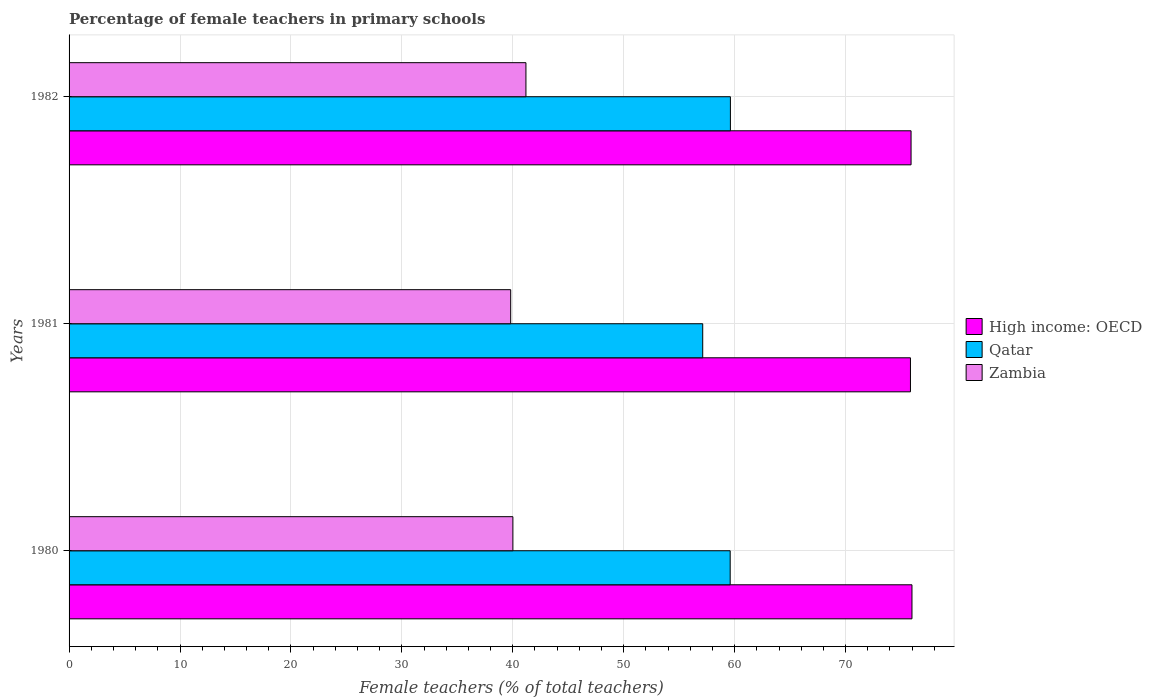How many different coloured bars are there?
Keep it short and to the point. 3. How many groups of bars are there?
Offer a very short reply. 3. Are the number of bars per tick equal to the number of legend labels?
Ensure brevity in your answer.  Yes. Are the number of bars on each tick of the Y-axis equal?
Your answer should be compact. Yes. How many bars are there on the 2nd tick from the top?
Give a very brief answer. 3. What is the label of the 1st group of bars from the top?
Keep it short and to the point. 1982. In how many cases, is the number of bars for a given year not equal to the number of legend labels?
Your answer should be very brief. 0. What is the percentage of female teachers in High income: OECD in 1981?
Offer a terse response. 75.85. Across all years, what is the maximum percentage of female teachers in Qatar?
Your answer should be very brief. 59.62. Across all years, what is the minimum percentage of female teachers in High income: OECD?
Give a very brief answer. 75.85. In which year was the percentage of female teachers in High income: OECD maximum?
Ensure brevity in your answer.  1980. What is the total percentage of female teachers in Qatar in the graph?
Ensure brevity in your answer.  176.34. What is the difference between the percentage of female teachers in High income: OECD in 1980 and that in 1982?
Your response must be concise. 0.08. What is the difference between the percentage of female teachers in High income: OECD in 1980 and the percentage of female teachers in Zambia in 1982?
Provide a succinct answer. 34.8. What is the average percentage of female teachers in High income: OECD per year?
Offer a terse response. 75.91. In the year 1982, what is the difference between the percentage of female teachers in High income: OECD and percentage of female teachers in Zambia?
Provide a succinct answer. 34.72. In how many years, is the percentage of female teachers in Qatar greater than 28 %?
Your answer should be compact. 3. What is the ratio of the percentage of female teachers in High income: OECD in 1980 to that in 1982?
Give a very brief answer. 1. What is the difference between the highest and the second highest percentage of female teachers in Zambia?
Offer a very short reply. 1.18. What is the difference between the highest and the lowest percentage of female teachers in Qatar?
Offer a very short reply. 2.5. In how many years, is the percentage of female teachers in Qatar greater than the average percentage of female teachers in Qatar taken over all years?
Your answer should be compact. 2. Is the sum of the percentage of female teachers in Qatar in 1980 and 1981 greater than the maximum percentage of female teachers in High income: OECD across all years?
Offer a terse response. Yes. What does the 1st bar from the top in 1981 represents?
Your answer should be very brief. Zambia. What does the 3rd bar from the bottom in 1980 represents?
Your response must be concise. Zambia. Are all the bars in the graph horizontal?
Ensure brevity in your answer.  Yes. How many years are there in the graph?
Keep it short and to the point. 3. Are the values on the major ticks of X-axis written in scientific E-notation?
Your answer should be very brief. No. Where does the legend appear in the graph?
Give a very brief answer. Center right. How many legend labels are there?
Your response must be concise. 3. How are the legend labels stacked?
Your answer should be very brief. Vertical. What is the title of the graph?
Keep it short and to the point. Percentage of female teachers in primary schools. What is the label or title of the X-axis?
Provide a short and direct response. Female teachers (% of total teachers). What is the Female teachers (% of total teachers) in High income: OECD in 1980?
Your answer should be very brief. 75.99. What is the Female teachers (% of total teachers) in Qatar in 1980?
Your answer should be very brief. 59.6. What is the Female teachers (% of total teachers) in Zambia in 1980?
Offer a very short reply. 40.01. What is the Female teachers (% of total teachers) in High income: OECD in 1981?
Keep it short and to the point. 75.85. What is the Female teachers (% of total teachers) in Qatar in 1981?
Ensure brevity in your answer.  57.12. What is the Female teachers (% of total teachers) of Zambia in 1981?
Ensure brevity in your answer.  39.81. What is the Female teachers (% of total teachers) of High income: OECD in 1982?
Keep it short and to the point. 75.9. What is the Female teachers (% of total teachers) of Qatar in 1982?
Make the answer very short. 59.62. What is the Female teachers (% of total teachers) of Zambia in 1982?
Give a very brief answer. 41.18. Across all years, what is the maximum Female teachers (% of total teachers) in High income: OECD?
Give a very brief answer. 75.99. Across all years, what is the maximum Female teachers (% of total teachers) in Qatar?
Provide a short and direct response. 59.62. Across all years, what is the maximum Female teachers (% of total teachers) in Zambia?
Provide a succinct answer. 41.18. Across all years, what is the minimum Female teachers (% of total teachers) in High income: OECD?
Provide a succinct answer. 75.85. Across all years, what is the minimum Female teachers (% of total teachers) in Qatar?
Give a very brief answer. 57.12. Across all years, what is the minimum Female teachers (% of total teachers) in Zambia?
Your answer should be compact. 39.81. What is the total Female teachers (% of total teachers) of High income: OECD in the graph?
Provide a succinct answer. 227.74. What is the total Female teachers (% of total teachers) of Qatar in the graph?
Provide a succinct answer. 176.34. What is the total Female teachers (% of total teachers) in Zambia in the graph?
Keep it short and to the point. 121. What is the difference between the Female teachers (% of total teachers) in High income: OECD in 1980 and that in 1981?
Provide a succinct answer. 0.14. What is the difference between the Female teachers (% of total teachers) of Qatar in 1980 and that in 1981?
Ensure brevity in your answer.  2.48. What is the difference between the Female teachers (% of total teachers) in Zambia in 1980 and that in 1981?
Make the answer very short. 0.2. What is the difference between the Female teachers (% of total teachers) of High income: OECD in 1980 and that in 1982?
Your answer should be compact. 0.08. What is the difference between the Female teachers (% of total teachers) of Qatar in 1980 and that in 1982?
Ensure brevity in your answer.  -0.02. What is the difference between the Female teachers (% of total teachers) in Zambia in 1980 and that in 1982?
Your answer should be compact. -1.18. What is the difference between the Female teachers (% of total teachers) in High income: OECD in 1981 and that in 1982?
Give a very brief answer. -0.06. What is the difference between the Female teachers (% of total teachers) in Qatar in 1981 and that in 1982?
Give a very brief answer. -2.5. What is the difference between the Female teachers (% of total teachers) in Zambia in 1981 and that in 1982?
Ensure brevity in your answer.  -1.37. What is the difference between the Female teachers (% of total teachers) of High income: OECD in 1980 and the Female teachers (% of total teachers) of Qatar in 1981?
Make the answer very short. 18.86. What is the difference between the Female teachers (% of total teachers) of High income: OECD in 1980 and the Female teachers (% of total teachers) of Zambia in 1981?
Your answer should be very brief. 36.18. What is the difference between the Female teachers (% of total teachers) of Qatar in 1980 and the Female teachers (% of total teachers) of Zambia in 1981?
Your answer should be compact. 19.79. What is the difference between the Female teachers (% of total teachers) of High income: OECD in 1980 and the Female teachers (% of total teachers) of Qatar in 1982?
Your response must be concise. 16.37. What is the difference between the Female teachers (% of total teachers) in High income: OECD in 1980 and the Female teachers (% of total teachers) in Zambia in 1982?
Your answer should be compact. 34.8. What is the difference between the Female teachers (% of total teachers) of Qatar in 1980 and the Female teachers (% of total teachers) of Zambia in 1982?
Your answer should be compact. 18.41. What is the difference between the Female teachers (% of total teachers) of High income: OECD in 1981 and the Female teachers (% of total teachers) of Qatar in 1982?
Your answer should be compact. 16.23. What is the difference between the Female teachers (% of total teachers) in High income: OECD in 1981 and the Female teachers (% of total teachers) in Zambia in 1982?
Keep it short and to the point. 34.66. What is the difference between the Female teachers (% of total teachers) of Qatar in 1981 and the Female teachers (% of total teachers) of Zambia in 1982?
Provide a short and direct response. 15.94. What is the average Female teachers (% of total teachers) of High income: OECD per year?
Offer a terse response. 75.91. What is the average Female teachers (% of total teachers) in Qatar per year?
Your answer should be compact. 58.78. What is the average Female teachers (% of total teachers) of Zambia per year?
Give a very brief answer. 40.33. In the year 1980, what is the difference between the Female teachers (% of total teachers) in High income: OECD and Female teachers (% of total teachers) in Qatar?
Offer a very short reply. 16.39. In the year 1980, what is the difference between the Female teachers (% of total teachers) in High income: OECD and Female teachers (% of total teachers) in Zambia?
Keep it short and to the point. 35.98. In the year 1980, what is the difference between the Female teachers (% of total teachers) of Qatar and Female teachers (% of total teachers) of Zambia?
Give a very brief answer. 19.59. In the year 1981, what is the difference between the Female teachers (% of total teachers) in High income: OECD and Female teachers (% of total teachers) in Qatar?
Provide a short and direct response. 18.73. In the year 1981, what is the difference between the Female teachers (% of total teachers) in High income: OECD and Female teachers (% of total teachers) in Zambia?
Give a very brief answer. 36.04. In the year 1981, what is the difference between the Female teachers (% of total teachers) in Qatar and Female teachers (% of total teachers) in Zambia?
Make the answer very short. 17.31. In the year 1982, what is the difference between the Female teachers (% of total teachers) of High income: OECD and Female teachers (% of total teachers) of Qatar?
Provide a short and direct response. 16.29. In the year 1982, what is the difference between the Female teachers (% of total teachers) in High income: OECD and Female teachers (% of total teachers) in Zambia?
Offer a terse response. 34.72. In the year 1982, what is the difference between the Female teachers (% of total teachers) of Qatar and Female teachers (% of total teachers) of Zambia?
Your answer should be compact. 18.43. What is the ratio of the Female teachers (% of total teachers) in Qatar in 1980 to that in 1981?
Offer a terse response. 1.04. What is the ratio of the Female teachers (% of total teachers) of Qatar in 1980 to that in 1982?
Keep it short and to the point. 1. What is the ratio of the Female teachers (% of total teachers) of Zambia in 1980 to that in 1982?
Provide a short and direct response. 0.97. What is the ratio of the Female teachers (% of total teachers) in Qatar in 1981 to that in 1982?
Make the answer very short. 0.96. What is the ratio of the Female teachers (% of total teachers) in Zambia in 1981 to that in 1982?
Your answer should be compact. 0.97. What is the difference between the highest and the second highest Female teachers (% of total teachers) in High income: OECD?
Your response must be concise. 0.08. What is the difference between the highest and the second highest Female teachers (% of total teachers) of Qatar?
Make the answer very short. 0.02. What is the difference between the highest and the second highest Female teachers (% of total teachers) in Zambia?
Offer a very short reply. 1.18. What is the difference between the highest and the lowest Female teachers (% of total teachers) of High income: OECD?
Offer a very short reply. 0.14. What is the difference between the highest and the lowest Female teachers (% of total teachers) in Qatar?
Give a very brief answer. 2.5. What is the difference between the highest and the lowest Female teachers (% of total teachers) in Zambia?
Keep it short and to the point. 1.37. 